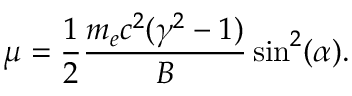<formula> <loc_0><loc_0><loc_500><loc_500>\mu = \frac { 1 } { 2 } \frac { m _ { e } c ^ { 2 } ( \gamma ^ { 2 } - 1 ) } { B } \sin ^ { 2 } ( \alpha ) .</formula> 